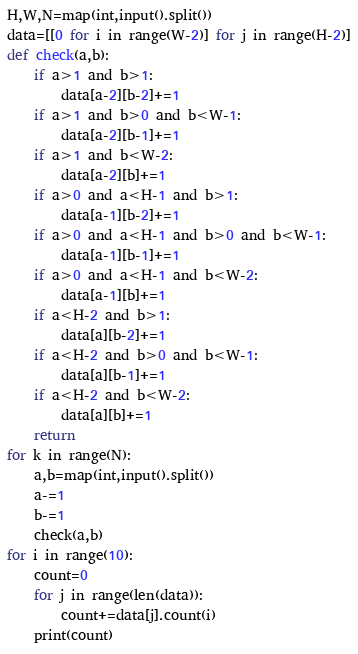<code> <loc_0><loc_0><loc_500><loc_500><_Python_>H,W,N=map(int,input().split())
data=[[0 for i in range(W-2)] for j in range(H-2)]
def check(a,b):
    if a>1 and b>1:
        data[a-2][b-2]+=1
    if a>1 and b>0 and b<W-1:
        data[a-2][b-1]+=1
    if a>1 and b<W-2:
        data[a-2][b]+=1
    if a>0 and a<H-1 and b>1:
        data[a-1][b-2]+=1
    if a>0 and a<H-1 and b>0 and b<W-1:
        data[a-1][b-1]+=1
    if a>0 and a<H-1 and b<W-2:
        data[a-1][b]+=1
    if a<H-2 and b>1:
        data[a][b-2]+=1
    if a<H-2 and b>0 and b<W-1:
        data[a][b-1]+=1
    if a<H-2 and b<W-2:
        data[a][b]+=1
    return
for k in range(N):
    a,b=map(int,input().split())
    a-=1
    b-=1
    check(a,b)
for i in range(10):
    count=0
    for j in range(len(data)):
        count+=data[j].count(i)
    print(count)</code> 